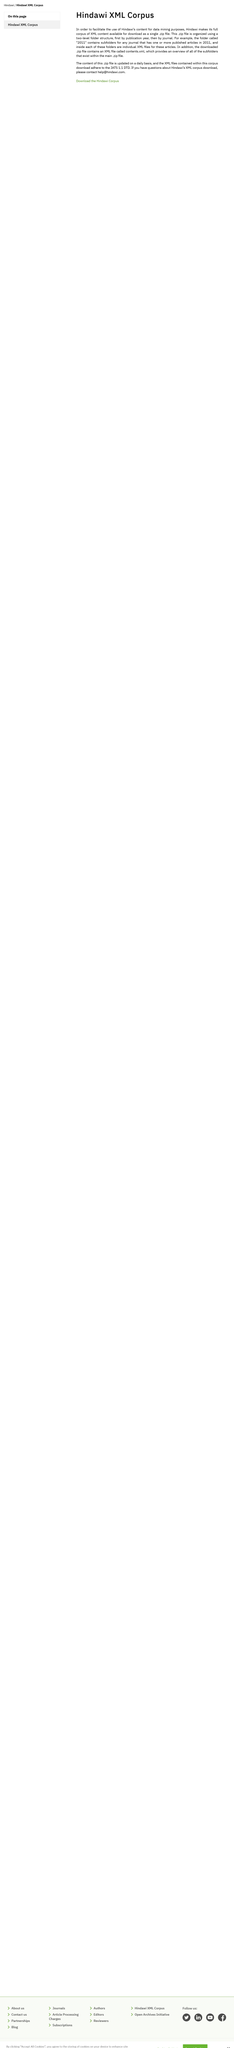Point out several critical features in this image. The Hindawi XML Corpus has a two-level folder structure with two levels. To contact Hindawi for questions about the XML corpus download, please use the email address [help@hindawi.com](mailto:help@hindawi.com). The Hindawi XML Corpus is updated daily with a new .zip file. 